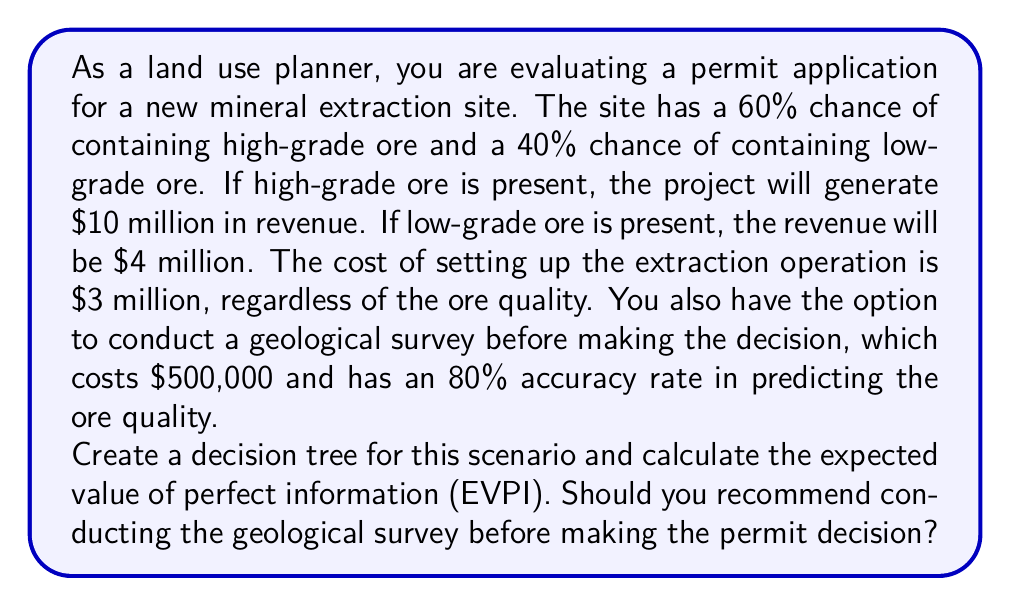Solve this math problem. Let's approach this problem step by step:

1. First, let's calculate the expected value (EV) of proceeding without the survey:

   EV = (0.6 × ($10M - $3M)) + (0.4 × ($4M - $3M))
      = 0.6 × $7M + 0.4 × $1M
      = $4.2M + $0.4M
      = $4.6M

2. Now, let's calculate the EV with perfect information:

   EV (high-grade) = $10M - $3M = $7M
   EV (low-grade) = $4M - $3M = $1M

   EV with perfect information = (0.6 × $7M) + (0.4 × $1M) = $4.6M

3. Calculate the Expected Value of Perfect Information (EVPI):

   EVPI = EV with perfect information - EV without information
        = $4.6M - $4.6M = $0

4. Now, let's consider the geological survey with 80% accuracy:

   Let's create a decision tree:

   [asy]
   import geometry;

   // Decision node
   dot((0,0));
   label("D", (0,0), W);

   // Chance nodes
   dot((2,1)); dot((2,-1));
   label("C", (2,1), NE);
   label("C", (2,-1), SE);

   // Outcomes
   label("$5.9M", (4,1.5), E);
   label("$0.5M", (4,0.5), E);
   label("$5.9M", (4,-0.5), E);
   label("$0.5M", (4,-1.5), E);

   // Lines
   draw((0,0)--(2,1));
   draw((0,0)--(2,-1));
   draw((2,1)--(4,1.5));
   draw((2,1)--(4,0.5));
   draw((2,-1)--(4,-0.5));
   draw((2,-1)--(4,-1.5));

   // Labels
   label("Survey", (1,0.5), N);
   label("No Survey", (1,-0.5), S);
   label("High (0.552)", (3,1.25), N);
   label("Low (0.048)", (3,0.75), S);
   label("High (0.048)", (3,-0.75), N);
   label("Low (0.352)", (3,-1.25), S);
   [/asy]

   P(High|Positive) = (0.8 × 0.6) / (0.8 × 0.6 + 0.2 × 0.4) = 0.923
   P(Low|Positive) = 1 - 0.923 = 0.077

   P(High|Negative) = (0.2 × 0.6) / (0.2 × 0.6 + 0.8 × 0.4) = 0.12
   P(Low|Negative) = 1 - 0.12 = 0.88

   EV(Positive) = 0.923 × $7M + 0.077 × $1M = $6.538M
   EV(Negative) = 0.12 × $7M + 0.88 × $1M = $1.72M

   P(Positive) = 0.8 × 0.6 + 0.2 × 0.4 = 0.56
   P(Negative) = 1 - 0.56 = 0.44

   EV(Survey) = 0.56 × $6.538M + 0.44 × $1.72M - $0.5M = $3.98M

5. Compare EV(Survey) with EV(No Survey):

   EV(Survey) = $3.98M
   EV(No Survey) = $4.6M
Answer: The Expected Value of Perfect Information (EVPI) is $0. The expected value of conducting the survey ($3.98M) is less than the expected value of proceeding without the survey ($4.6M). Therefore, you should not recommend conducting the geological survey before making the permit decision. 